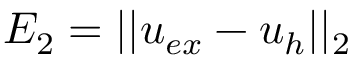Convert formula to latex. <formula><loc_0><loc_0><loc_500><loc_500>E _ { 2 } = | | u _ { e x } - u _ { h } | | _ { 2 }</formula> 